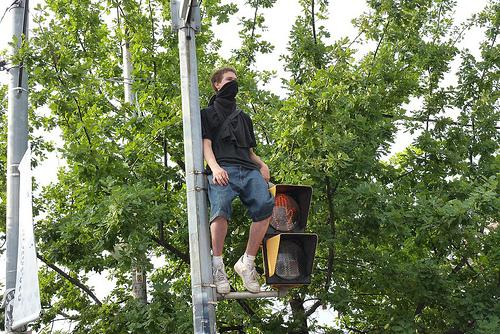Question: who is in the pole?
Choices:
A. The child.
B. The woman.
C. The guy.
D. The teenagers.
Answer with the letter. Answer: C Question: what is he on?
Choices:
A. The pole.
B. A can.
C. A chair.
D. A bed.
Answer with the letter. Answer: A Question: what is next to him?
Choices:
A. Nightstand.
B. A couch.
C. Lights.
D. A chair.
Answer with the letter. Answer: C Question: what color are the trees?
Choices:
A. Brown.
B. Green.
C. Orange.
D. White.
Answer with the letter. Answer: B Question: how many guys?
Choices:
A. 2.
B. 3.
C. 1.
D. 4.
Answer with the letter. Answer: C 